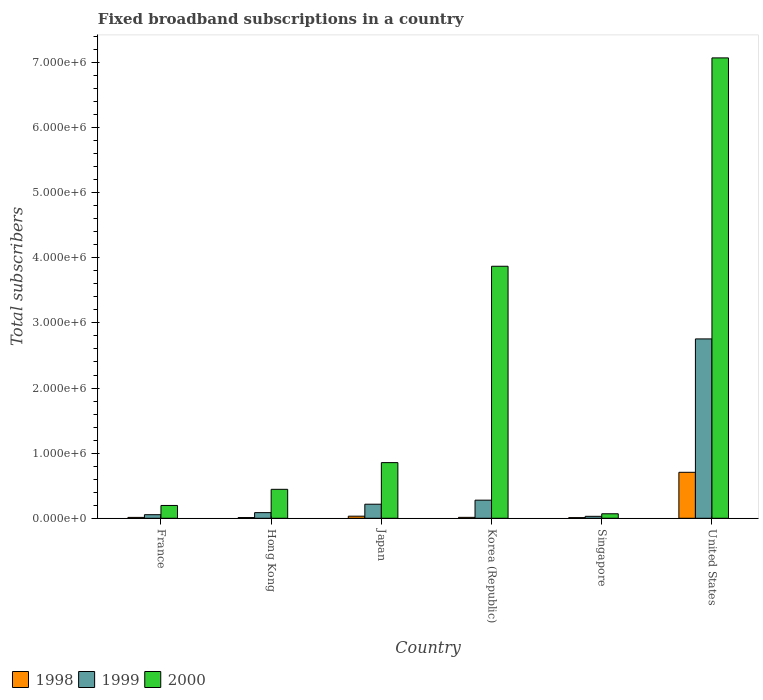How many bars are there on the 6th tick from the left?
Keep it short and to the point. 3. In how many cases, is the number of bars for a given country not equal to the number of legend labels?
Offer a very short reply. 0. What is the number of broadband subscriptions in 1999 in Hong Kong?
Keep it short and to the point. 8.65e+04. Across all countries, what is the maximum number of broadband subscriptions in 2000?
Offer a very short reply. 7.07e+06. In which country was the number of broadband subscriptions in 1998 minimum?
Your answer should be compact. Singapore. What is the total number of broadband subscriptions in 1999 in the graph?
Ensure brevity in your answer.  3.42e+06. What is the difference between the number of broadband subscriptions in 1999 in Singapore and that in United States?
Your answer should be compact. -2.72e+06. What is the difference between the number of broadband subscriptions in 1998 in United States and the number of broadband subscriptions in 1999 in Japan?
Your answer should be compact. 4.90e+05. What is the average number of broadband subscriptions in 1998 per country?
Provide a succinct answer. 1.31e+05. What is the difference between the number of broadband subscriptions of/in 1998 and number of broadband subscriptions of/in 1999 in Hong Kong?
Offer a terse response. -7.55e+04. In how many countries, is the number of broadband subscriptions in 1999 greater than 1600000?
Make the answer very short. 1. What is the ratio of the number of broadband subscriptions in 2000 in Singapore to that in United States?
Offer a terse response. 0.01. Is the number of broadband subscriptions in 1999 in Japan less than that in United States?
Give a very brief answer. Yes. Is the difference between the number of broadband subscriptions in 1998 in Hong Kong and United States greater than the difference between the number of broadband subscriptions in 1999 in Hong Kong and United States?
Your answer should be very brief. Yes. What is the difference between the highest and the second highest number of broadband subscriptions in 1999?
Offer a very short reply. -2.48e+06. What is the difference between the highest and the lowest number of broadband subscriptions in 1998?
Keep it short and to the point. 6.96e+05. In how many countries, is the number of broadband subscriptions in 1999 greater than the average number of broadband subscriptions in 1999 taken over all countries?
Provide a succinct answer. 1. Is the sum of the number of broadband subscriptions in 1998 in France and United States greater than the maximum number of broadband subscriptions in 2000 across all countries?
Make the answer very short. No. What does the 1st bar from the right in Korea (Republic) represents?
Give a very brief answer. 2000. Are all the bars in the graph horizontal?
Provide a succinct answer. No. What is the difference between two consecutive major ticks on the Y-axis?
Offer a very short reply. 1.00e+06. Does the graph contain grids?
Your answer should be compact. No. Where does the legend appear in the graph?
Offer a very short reply. Bottom left. How many legend labels are there?
Your answer should be compact. 3. What is the title of the graph?
Ensure brevity in your answer.  Fixed broadband subscriptions in a country. Does "1968" appear as one of the legend labels in the graph?
Your answer should be very brief. No. What is the label or title of the X-axis?
Ensure brevity in your answer.  Country. What is the label or title of the Y-axis?
Give a very brief answer. Total subscribers. What is the Total subscribers of 1998 in France?
Your response must be concise. 1.35e+04. What is the Total subscribers of 1999 in France?
Keep it short and to the point. 5.50e+04. What is the Total subscribers of 2000 in France?
Your response must be concise. 1.97e+05. What is the Total subscribers in 1998 in Hong Kong?
Your response must be concise. 1.10e+04. What is the Total subscribers of 1999 in Hong Kong?
Make the answer very short. 8.65e+04. What is the Total subscribers of 2000 in Hong Kong?
Your answer should be compact. 4.44e+05. What is the Total subscribers of 1998 in Japan?
Your answer should be compact. 3.20e+04. What is the Total subscribers in 1999 in Japan?
Your response must be concise. 2.16e+05. What is the Total subscribers in 2000 in Japan?
Provide a short and direct response. 8.55e+05. What is the Total subscribers in 1998 in Korea (Republic)?
Offer a terse response. 1.40e+04. What is the Total subscribers of 1999 in Korea (Republic)?
Your response must be concise. 2.78e+05. What is the Total subscribers in 2000 in Korea (Republic)?
Keep it short and to the point. 3.87e+06. What is the Total subscribers of 1998 in Singapore?
Provide a succinct answer. 10000. What is the Total subscribers in 1999 in Singapore?
Keep it short and to the point. 3.00e+04. What is the Total subscribers in 2000 in Singapore?
Provide a short and direct response. 6.90e+04. What is the Total subscribers of 1998 in United States?
Provide a short and direct response. 7.06e+05. What is the Total subscribers of 1999 in United States?
Your response must be concise. 2.75e+06. What is the Total subscribers of 2000 in United States?
Offer a very short reply. 7.07e+06. Across all countries, what is the maximum Total subscribers of 1998?
Ensure brevity in your answer.  7.06e+05. Across all countries, what is the maximum Total subscribers of 1999?
Make the answer very short. 2.75e+06. Across all countries, what is the maximum Total subscribers in 2000?
Provide a short and direct response. 7.07e+06. Across all countries, what is the minimum Total subscribers in 1999?
Provide a short and direct response. 3.00e+04. Across all countries, what is the minimum Total subscribers in 2000?
Offer a terse response. 6.90e+04. What is the total Total subscribers of 1998 in the graph?
Keep it short and to the point. 7.86e+05. What is the total Total subscribers in 1999 in the graph?
Keep it short and to the point. 3.42e+06. What is the total Total subscribers in 2000 in the graph?
Give a very brief answer. 1.25e+07. What is the difference between the Total subscribers of 1998 in France and that in Hong Kong?
Your response must be concise. 2464. What is the difference between the Total subscribers in 1999 in France and that in Hong Kong?
Keep it short and to the point. -3.15e+04. What is the difference between the Total subscribers in 2000 in France and that in Hong Kong?
Offer a terse response. -2.48e+05. What is the difference between the Total subscribers of 1998 in France and that in Japan?
Keep it short and to the point. -1.85e+04. What is the difference between the Total subscribers of 1999 in France and that in Japan?
Ensure brevity in your answer.  -1.61e+05. What is the difference between the Total subscribers of 2000 in France and that in Japan?
Ensure brevity in your answer.  -6.58e+05. What is the difference between the Total subscribers of 1998 in France and that in Korea (Republic)?
Your response must be concise. -536. What is the difference between the Total subscribers of 1999 in France and that in Korea (Republic)?
Give a very brief answer. -2.23e+05. What is the difference between the Total subscribers of 2000 in France and that in Korea (Republic)?
Provide a succinct answer. -3.67e+06. What is the difference between the Total subscribers in 1998 in France and that in Singapore?
Your response must be concise. 3464. What is the difference between the Total subscribers in 1999 in France and that in Singapore?
Your response must be concise. 2.50e+04. What is the difference between the Total subscribers of 2000 in France and that in Singapore?
Your answer should be compact. 1.28e+05. What is the difference between the Total subscribers of 1998 in France and that in United States?
Offer a very short reply. -6.92e+05. What is the difference between the Total subscribers in 1999 in France and that in United States?
Your answer should be very brief. -2.70e+06. What is the difference between the Total subscribers of 2000 in France and that in United States?
Your answer should be compact. -6.87e+06. What is the difference between the Total subscribers of 1998 in Hong Kong and that in Japan?
Your answer should be very brief. -2.10e+04. What is the difference between the Total subscribers in 1999 in Hong Kong and that in Japan?
Your response must be concise. -1.30e+05. What is the difference between the Total subscribers of 2000 in Hong Kong and that in Japan?
Make the answer very short. -4.10e+05. What is the difference between the Total subscribers in 1998 in Hong Kong and that in Korea (Republic)?
Make the answer very short. -3000. What is the difference between the Total subscribers of 1999 in Hong Kong and that in Korea (Republic)?
Provide a short and direct response. -1.92e+05. What is the difference between the Total subscribers of 2000 in Hong Kong and that in Korea (Republic)?
Provide a succinct answer. -3.43e+06. What is the difference between the Total subscribers in 1999 in Hong Kong and that in Singapore?
Make the answer very short. 5.65e+04. What is the difference between the Total subscribers of 2000 in Hong Kong and that in Singapore?
Provide a succinct answer. 3.75e+05. What is the difference between the Total subscribers of 1998 in Hong Kong and that in United States?
Offer a terse response. -6.95e+05. What is the difference between the Total subscribers in 1999 in Hong Kong and that in United States?
Provide a short and direct response. -2.67e+06. What is the difference between the Total subscribers of 2000 in Hong Kong and that in United States?
Give a very brief answer. -6.63e+06. What is the difference between the Total subscribers in 1998 in Japan and that in Korea (Republic)?
Your answer should be very brief. 1.80e+04. What is the difference between the Total subscribers of 1999 in Japan and that in Korea (Republic)?
Provide a succinct answer. -6.20e+04. What is the difference between the Total subscribers of 2000 in Japan and that in Korea (Republic)?
Make the answer very short. -3.02e+06. What is the difference between the Total subscribers of 1998 in Japan and that in Singapore?
Provide a short and direct response. 2.20e+04. What is the difference between the Total subscribers of 1999 in Japan and that in Singapore?
Provide a short and direct response. 1.86e+05. What is the difference between the Total subscribers in 2000 in Japan and that in Singapore?
Provide a succinct answer. 7.86e+05. What is the difference between the Total subscribers of 1998 in Japan and that in United States?
Your answer should be very brief. -6.74e+05. What is the difference between the Total subscribers in 1999 in Japan and that in United States?
Give a very brief answer. -2.54e+06. What is the difference between the Total subscribers in 2000 in Japan and that in United States?
Give a very brief answer. -6.22e+06. What is the difference between the Total subscribers in 1998 in Korea (Republic) and that in Singapore?
Your response must be concise. 4000. What is the difference between the Total subscribers in 1999 in Korea (Republic) and that in Singapore?
Keep it short and to the point. 2.48e+05. What is the difference between the Total subscribers of 2000 in Korea (Republic) and that in Singapore?
Keep it short and to the point. 3.80e+06. What is the difference between the Total subscribers in 1998 in Korea (Republic) and that in United States?
Make the answer very short. -6.92e+05. What is the difference between the Total subscribers of 1999 in Korea (Republic) and that in United States?
Ensure brevity in your answer.  -2.48e+06. What is the difference between the Total subscribers in 2000 in Korea (Republic) and that in United States?
Give a very brief answer. -3.20e+06. What is the difference between the Total subscribers of 1998 in Singapore and that in United States?
Offer a terse response. -6.96e+05. What is the difference between the Total subscribers of 1999 in Singapore and that in United States?
Provide a short and direct response. -2.72e+06. What is the difference between the Total subscribers in 2000 in Singapore and that in United States?
Keep it short and to the point. -7.00e+06. What is the difference between the Total subscribers of 1998 in France and the Total subscribers of 1999 in Hong Kong?
Your answer should be compact. -7.30e+04. What is the difference between the Total subscribers in 1998 in France and the Total subscribers in 2000 in Hong Kong?
Give a very brief answer. -4.31e+05. What is the difference between the Total subscribers in 1999 in France and the Total subscribers in 2000 in Hong Kong?
Your response must be concise. -3.89e+05. What is the difference between the Total subscribers of 1998 in France and the Total subscribers of 1999 in Japan?
Make the answer very short. -2.03e+05. What is the difference between the Total subscribers in 1998 in France and the Total subscribers in 2000 in Japan?
Provide a short and direct response. -8.41e+05. What is the difference between the Total subscribers of 1999 in France and the Total subscribers of 2000 in Japan?
Give a very brief answer. -8.00e+05. What is the difference between the Total subscribers of 1998 in France and the Total subscribers of 1999 in Korea (Republic)?
Provide a short and direct response. -2.65e+05. What is the difference between the Total subscribers of 1998 in France and the Total subscribers of 2000 in Korea (Republic)?
Your response must be concise. -3.86e+06. What is the difference between the Total subscribers of 1999 in France and the Total subscribers of 2000 in Korea (Republic)?
Your response must be concise. -3.82e+06. What is the difference between the Total subscribers in 1998 in France and the Total subscribers in 1999 in Singapore?
Provide a short and direct response. -1.65e+04. What is the difference between the Total subscribers of 1998 in France and the Total subscribers of 2000 in Singapore?
Keep it short and to the point. -5.55e+04. What is the difference between the Total subscribers of 1999 in France and the Total subscribers of 2000 in Singapore?
Your answer should be compact. -1.40e+04. What is the difference between the Total subscribers in 1998 in France and the Total subscribers in 1999 in United States?
Your answer should be compact. -2.74e+06. What is the difference between the Total subscribers in 1998 in France and the Total subscribers in 2000 in United States?
Offer a very short reply. -7.06e+06. What is the difference between the Total subscribers of 1999 in France and the Total subscribers of 2000 in United States?
Give a very brief answer. -7.01e+06. What is the difference between the Total subscribers in 1998 in Hong Kong and the Total subscribers in 1999 in Japan?
Provide a succinct answer. -2.05e+05. What is the difference between the Total subscribers in 1998 in Hong Kong and the Total subscribers in 2000 in Japan?
Keep it short and to the point. -8.44e+05. What is the difference between the Total subscribers in 1999 in Hong Kong and the Total subscribers in 2000 in Japan?
Give a very brief answer. -7.68e+05. What is the difference between the Total subscribers of 1998 in Hong Kong and the Total subscribers of 1999 in Korea (Republic)?
Keep it short and to the point. -2.67e+05. What is the difference between the Total subscribers in 1998 in Hong Kong and the Total subscribers in 2000 in Korea (Republic)?
Give a very brief answer. -3.86e+06. What is the difference between the Total subscribers in 1999 in Hong Kong and the Total subscribers in 2000 in Korea (Republic)?
Make the answer very short. -3.78e+06. What is the difference between the Total subscribers in 1998 in Hong Kong and the Total subscribers in 1999 in Singapore?
Your response must be concise. -1.90e+04. What is the difference between the Total subscribers of 1998 in Hong Kong and the Total subscribers of 2000 in Singapore?
Make the answer very short. -5.80e+04. What is the difference between the Total subscribers in 1999 in Hong Kong and the Total subscribers in 2000 in Singapore?
Keep it short and to the point. 1.75e+04. What is the difference between the Total subscribers in 1998 in Hong Kong and the Total subscribers in 1999 in United States?
Offer a very short reply. -2.74e+06. What is the difference between the Total subscribers of 1998 in Hong Kong and the Total subscribers of 2000 in United States?
Provide a short and direct response. -7.06e+06. What is the difference between the Total subscribers of 1999 in Hong Kong and the Total subscribers of 2000 in United States?
Your answer should be compact. -6.98e+06. What is the difference between the Total subscribers of 1998 in Japan and the Total subscribers of 1999 in Korea (Republic)?
Offer a very short reply. -2.46e+05. What is the difference between the Total subscribers in 1998 in Japan and the Total subscribers in 2000 in Korea (Republic)?
Give a very brief answer. -3.84e+06. What is the difference between the Total subscribers in 1999 in Japan and the Total subscribers in 2000 in Korea (Republic)?
Offer a very short reply. -3.65e+06. What is the difference between the Total subscribers of 1998 in Japan and the Total subscribers of 1999 in Singapore?
Your answer should be compact. 2000. What is the difference between the Total subscribers of 1998 in Japan and the Total subscribers of 2000 in Singapore?
Offer a very short reply. -3.70e+04. What is the difference between the Total subscribers of 1999 in Japan and the Total subscribers of 2000 in Singapore?
Provide a short and direct response. 1.47e+05. What is the difference between the Total subscribers in 1998 in Japan and the Total subscribers in 1999 in United States?
Offer a very short reply. -2.72e+06. What is the difference between the Total subscribers in 1998 in Japan and the Total subscribers in 2000 in United States?
Provide a succinct answer. -7.04e+06. What is the difference between the Total subscribers in 1999 in Japan and the Total subscribers in 2000 in United States?
Give a very brief answer. -6.85e+06. What is the difference between the Total subscribers of 1998 in Korea (Republic) and the Total subscribers of 1999 in Singapore?
Keep it short and to the point. -1.60e+04. What is the difference between the Total subscribers of 1998 in Korea (Republic) and the Total subscribers of 2000 in Singapore?
Your answer should be compact. -5.50e+04. What is the difference between the Total subscribers of 1999 in Korea (Republic) and the Total subscribers of 2000 in Singapore?
Your answer should be very brief. 2.09e+05. What is the difference between the Total subscribers in 1998 in Korea (Republic) and the Total subscribers in 1999 in United States?
Keep it short and to the point. -2.74e+06. What is the difference between the Total subscribers in 1998 in Korea (Republic) and the Total subscribers in 2000 in United States?
Make the answer very short. -7.06e+06. What is the difference between the Total subscribers of 1999 in Korea (Republic) and the Total subscribers of 2000 in United States?
Your response must be concise. -6.79e+06. What is the difference between the Total subscribers of 1998 in Singapore and the Total subscribers of 1999 in United States?
Give a very brief answer. -2.74e+06. What is the difference between the Total subscribers in 1998 in Singapore and the Total subscribers in 2000 in United States?
Your answer should be compact. -7.06e+06. What is the difference between the Total subscribers of 1999 in Singapore and the Total subscribers of 2000 in United States?
Provide a short and direct response. -7.04e+06. What is the average Total subscribers in 1998 per country?
Provide a short and direct response. 1.31e+05. What is the average Total subscribers of 1999 per country?
Provide a short and direct response. 5.70e+05. What is the average Total subscribers in 2000 per country?
Give a very brief answer. 2.08e+06. What is the difference between the Total subscribers of 1998 and Total subscribers of 1999 in France?
Keep it short and to the point. -4.15e+04. What is the difference between the Total subscribers of 1998 and Total subscribers of 2000 in France?
Provide a succinct answer. -1.83e+05. What is the difference between the Total subscribers in 1999 and Total subscribers in 2000 in France?
Keep it short and to the point. -1.42e+05. What is the difference between the Total subscribers in 1998 and Total subscribers in 1999 in Hong Kong?
Your response must be concise. -7.55e+04. What is the difference between the Total subscribers in 1998 and Total subscribers in 2000 in Hong Kong?
Make the answer very short. -4.33e+05. What is the difference between the Total subscribers of 1999 and Total subscribers of 2000 in Hong Kong?
Provide a short and direct response. -3.58e+05. What is the difference between the Total subscribers of 1998 and Total subscribers of 1999 in Japan?
Keep it short and to the point. -1.84e+05. What is the difference between the Total subscribers in 1998 and Total subscribers in 2000 in Japan?
Make the answer very short. -8.23e+05. What is the difference between the Total subscribers of 1999 and Total subscribers of 2000 in Japan?
Make the answer very short. -6.39e+05. What is the difference between the Total subscribers of 1998 and Total subscribers of 1999 in Korea (Republic)?
Your answer should be very brief. -2.64e+05. What is the difference between the Total subscribers of 1998 and Total subscribers of 2000 in Korea (Republic)?
Keep it short and to the point. -3.86e+06. What is the difference between the Total subscribers of 1999 and Total subscribers of 2000 in Korea (Republic)?
Your answer should be very brief. -3.59e+06. What is the difference between the Total subscribers in 1998 and Total subscribers in 1999 in Singapore?
Your answer should be compact. -2.00e+04. What is the difference between the Total subscribers in 1998 and Total subscribers in 2000 in Singapore?
Offer a terse response. -5.90e+04. What is the difference between the Total subscribers of 1999 and Total subscribers of 2000 in Singapore?
Offer a very short reply. -3.90e+04. What is the difference between the Total subscribers in 1998 and Total subscribers in 1999 in United States?
Offer a terse response. -2.05e+06. What is the difference between the Total subscribers of 1998 and Total subscribers of 2000 in United States?
Your response must be concise. -6.36e+06. What is the difference between the Total subscribers in 1999 and Total subscribers in 2000 in United States?
Provide a short and direct response. -4.32e+06. What is the ratio of the Total subscribers of 1998 in France to that in Hong Kong?
Ensure brevity in your answer.  1.22. What is the ratio of the Total subscribers of 1999 in France to that in Hong Kong?
Ensure brevity in your answer.  0.64. What is the ratio of the Total subscribers of 2000 in France to that in Hong Kong?
Offer a terse response. 0.44. What is the ratio of the Total subscribers in 1998 in France to that in Japan?
Ensure brevity in your answer.  0.42. What is the ratio of the Total subscribers in 1999 in France to that in Japan?
Keep it short and to the point. 0.25. What is the ratio of the Total subscribers in 2000 in France to that in Japan?
Keep it short and to the point. 0.23. What is the ratio of the Total subscribers in 1998 in France to that in Korea (Republic)?
Provide a short and direct response. 0.96. What is the ratio of the Total subscribers of 1999 in France to that in Korea (Republic)?
Offer a very short reply. 0.2. What is the ratio of the Total subscribers in 2000 in France to that in Korea (Republic)?
Your answer should be compact. 0.05. What is the ratio of the Total subscribers in 1998 in France to that in Singapore?
Your answer should be compact. 1.35. What is the ratio of the Total subscribers in 1999 in France to that in Singapore?
Your answer should be very brief. 1.83. What is the ratio of the Total subscribers of 2000 in France to that in Singapore?
Your answer should be compact. 2.85. What is the ratio of the Total subscribers in 1998 in France to that in United States?
Offer a very short reply. 0.02. What is the ratio of the Total subscribers of 2000 in France to that in United States?
Provide a succinct answer. 0.03. What is the ratio of the Total subscribers in 1998 in Hong Kong to that in Japan?
Offer a very short reply. 0.34. What is the ratio of the Total subscribers of 1999 in Hong Kong to that in Japan?
Offer a very short reply. 0.4. What is the ratio of the Total subscribers in 2000 in Hong Kong to that in Japan?
Your answer should be compact. 0.52. What is the ratio of the Total subscribers of 1998 in Hong Kong to that in Korea (Republic)?
Offer a very short reply. 0.79. What is the ratio of the Total subscribers of 1999 in Hong Kong to that in Korea (Republic)?
Offer a very short reply. 0.31. What is the ratio of the Total subscribers of 2000 in Hong Kong to that in Korea (Republic)?
Your response must be concise. 0.11. What is the ratio of the Total subscribers in 1999 in Hong Kong to that in Singapore?
Your answer should be compact. 2.88. What is the ratio of the Total subscribers of 2000 in Hong Kong to that in Singapore?
Make the answer very short. 6.44. What is the ratio of the Total subscribers in 1998 in Hong Kong to that in United States?
Your response must be concise. 0.02. What is the ratio of the Total subscribers of 1999 in Hong Kong to that in United States?
Ensure brevity in your answer.  0.03. What is the ratio of the Total subscribers of 2000 in Hong Kong to that in United States?
Ensure brevity in your answer.  0.06. What is the ratio of the Total subscribers in 1998 in Japan to that in Korea (Republic)?
Your answer should be compact. 2.29. What is the ratio of the Total subscribers in 1999 in Japan to that in Korea (Republic)?
Offer a terse response. 0.78. What is the ratio of the Total subscribers in 2000 in Japan to that in Korea (Republic)?
Provide a short and direct response. 0.22. What is the ratio of the Total subscribers of 1999 in Japan to that in Singapore?
Your answer should be very brief. 7.2. What is the ratio of the Total subscribers of 2000 in Japan to that in Singapore?
Provide a short and direct response. 12.39. What is the ratio of the Total subscribers of 1998 in Japan to that in United States?
Offer a terse response. 0.05. What is the ratio of the Total subscribers of 1999 in Japan to that in United States?
Keep it short and to the point. 0.08. What is the ratio of the Total subscribers of 2000 in Japan to that in United States?
Offer a terse response. 0.12. What is the ratio of the Total subscribers in 1998 in Korea (Republic) to that in Singapore?
Provide a succinct answer. 1.4. What is the ratio of the Total subscribers of 1999 in Korea (Republic) to that in Singapore?
Offer a very short reply. 9.27. What is the ratio of the Total subscribers in 2000 in Korea (Republic) to that in Singapore?
Ensure brevity in your answer.  56.09. What is the ratio of the Total subscribers of 1998 in Korea (Republic) to that in United States?
Your answer should be compact. 0.02. What is the ratio of the Total subscribers in 1999 in Korea (Republic) to that in United States?
Offer a very short reply. 0.1. What is the ratio of the Total subscribers of 2000 in Korea (Republic) to that in United States?
Make the answer very short. 0.55. What is the ratio of the Total subscribers of 1998 in Singapore to that in United States?
Your answer should be very brief. 0.01. What is the ratio of the Total subscribers of 1999 in Singapore to that in United States?
Make the answer very short. 0.01. What is the ratio of the Total subscribers in 2000 in Singapore to that in United States?
Your answer should be very brief. 0.01. What is the difference between the highest and the second highest Total subscribers in 1998?
Your answer should be compact. 6.74e+05. What is the difference between the highest and the second highest Total subscribers in 1999?
Give a very brief answer. 2.48e+06. What is the difference between the highest and the second highest Total subscribers of 2000?
Provide a short and direct response. 3.20e+06. What is the difference between the highest and the lowest Total subscribers in 1998?
Offer a terse response. 6.96e+05. What is the difference between the highest and the lowest Total subscribers in 1999?
Make the answer very short. 2.72e+06. What is the difference between the highest and the lowest Total subscribers in 2000?
Offer a very short reply. 7.00e+06. 